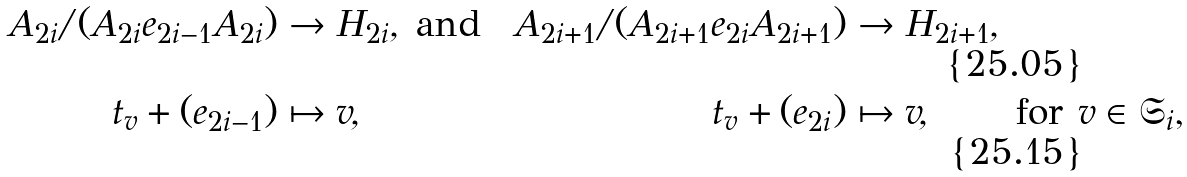Convert formula to latex. <formula><loc_0><loc_0><loc_500><loc_500>A _ { 2 i } / ( A _ { 2 i } e _ { 2 i - 1 } A _ { 2 i } ) & \to H _ { 2 i } , & & \text {and} & & & A _ { 2 i + 1 } / ( A _ { 2 i + 1 } e _ { 2 i } A _ { 2 i + 1 } ) & \to H _ { 2 i + 1 } , \\ t _ { v } + ( e _ { 2 i - 1 } ) & \mapsto v , & & & & & t _ { v } + ( e _ { 2 i } ) & \mapsto v , & & \text {for $v\in\mathfrak{S}_{i}$,}</formula> 